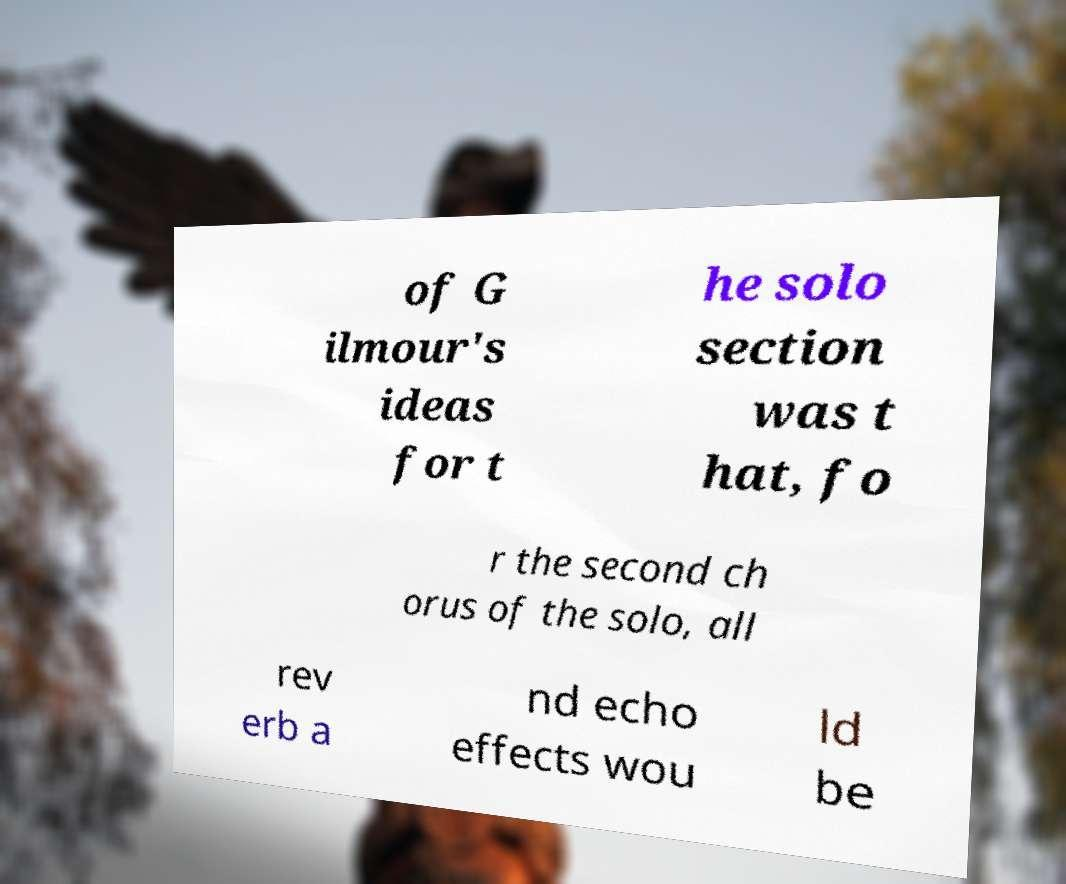Can you accurately transcribe the text from the provided image for me? of G ilmour's ideas for t he solo section was t hat, fo r the second ch orus of the solo, all rev erb a nd echo effects wou ld be 